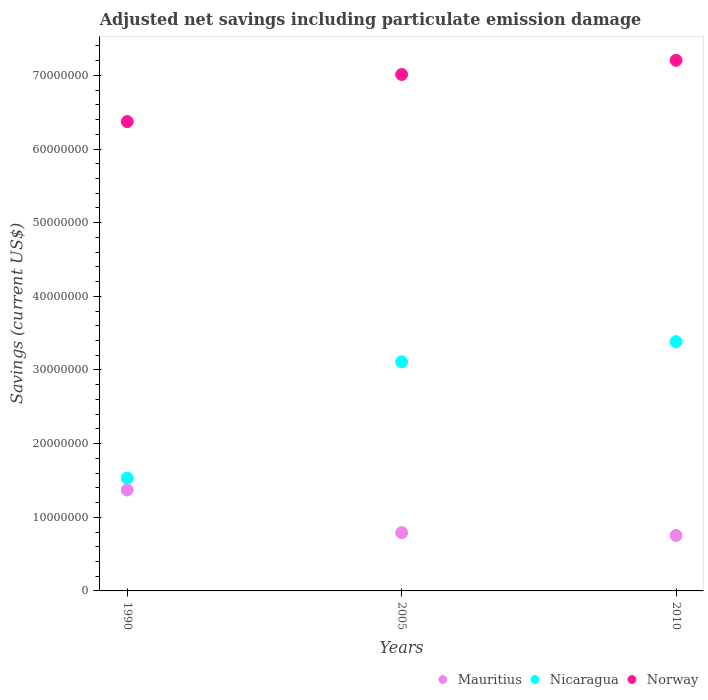How many different coloured dotlines are there?
Your answer should be compact. 3. Is the number of dotlines equal to the number of legend labels?
Offer a terse response. Yes. What is the net savings in Mauritius in 1990?
Keep it short and to the point. 1.37e+07. Across all years, what is the maximum net savings in Mauritius?
Offer a very short reply. 1.37e+07. Across all years, what is the minimum net savings in Norway?
Your response must be concise. 6.37e+07. In which year was the net savings in Mauritius maximum?
Provide a short and direct response. 1990. In which year was the net savings in Nicaragua minimum?
Your answer should be very brief. 1990. What is the total net savings in Norway in the graph?
Your response must be concise. 2.06e+08. What is the difference between the net savings in Nicaragua in 1990 and that in 2010?
Your response must be concise. -1.85e+07. What is the difference between the net savings in Mauritius in 2005 and the net savings in Norway in 2010?
Give a very brief answer. -6.41e+07. What is the average net savings in Nicaragua per year?
Your answer should be very brief. 2.68e+07. In the year 2005, what is the difference between the net savings in Nicaragua and net savings in Mauritius?
Your answer should be very brief. 2.32e+07. In how many years, is the net savings in Norway greater than 10000000 US$?
Provide a succinct answer. 3. What is the ratio of the net savings in Nicaragua in 1990 to that in 2005?
Offer a very short reply. 0.49. Is the difference between the net savings in Nicaragua in 1990 and 2005 greater than the difference between the net savings in Mauritius in 1990 and 2005?
Your answer should be very brief. No. What is the difference between the highest and the second highest net savings in Mauritius?
Give a very brief answer. 5.80e+06. What is the difference between the highest and the lowest net savings in Nicaragua?
Make the answer very short. 1.85e+07. In how many years, is the net savings in Norway greater than the average net savings in Norway taken over all years?
Your answer should be compact. 2. Is the sum of the net savings in Nicaragua in 1990 and 2005 greater than the maximum net savings in Norway across all years?
Your answer should be compact. No. Is the net savings in Mauritius strictly less than the net savings in Norway over the years?
Offer a very short reply. Yes. What is the difference between two consecutive major ticks on the Y-axis?
Keep it short and to the point. 1.00e+07. Are the values on the major ticks of Y-axis written in scientific E-notation?
Your response must be concise. No. Does the graph contain grids?
Offer a terse response. No. What is the title of the graph?
Your response must be concise. Adjusted net savings including particulate emission damage. Does "Mozambique" appear as one of the legend labels in the graph?
Provide a short and direct response. No. What is the label or title of the X-axis?
Your answer should be very brief. Years. What is the label or title of the Y-axis?
Make the answer very short. Savings (current US$). What is the Savings (current US$) of Mauritius in 1990?
Ensure brevity in your answer.  1.37e+07. What is the Savings (current US$) of Nicaragua in 1990?
Provide a short and direct response. 1.53e+07. What is the Savings (current US$) of Norway in 1990?
Ensure brevity in your answer.  6.37e+07. What is the Savings (current US$) of Mauritius in 2005?
Provide a short and direct response. 7.91e+06. What is the Savings (current US$) in Nicaragua in 2005?
Your answer should be very brief. 3.11e+07. What is the Savings (current US$) of Norway in 2005?
Provide a short and direct response. 7.01e+07. What is the Savings (current US$) of Mauritius in 2010?
Give a very brief answer. 7.53e+06. What is the Savings (current US$) of Nicaragua in 2010?
Provide a succinct answer. 3.38e+07. What is the Savings (current US$) of Norway in 2010?
Keep it short and to the point. 7.21e+07. Across all years, what is the maximum Savings (current US$) of Mauritius?
Ensure brevity in your answer.  1.37e+07. Across all years, what is the maximum Savings (current US$) of Nicaragua?
Your response must be concise. 3.38e+07. Across all years, what is the maximum Savings (current US$) of Norway?
Ensure brevity in your answer.  7.21e+07. Across all years, what is the minimum Savings (current US$) in Mauritius?
Give a very brief answer. 7.53e+06. Across all years, what is the minimum Savings (current US$) in Nicaragua?
Keep it short and to the point. 1.53e+07. Across all years, what is the minimum Savings (current US$) of Norway?
Ensure brevity in your answer.  6.37e+07. What is the total Savings (current US$) in Mauritius in the graph?
Offer a very short reply. 2.91e+07. What is the total Savings (current US$) in Nicaragua in the graph?
Offer a terse response. 8.03e+07. What is the total Savings (current US$) in Norway in the graph?
Offer a very short reply. 2.06e+08. What is the difference between the Savings (current US$) in Mauritius in 1990 and that in 2005?
Offer a terse response. 5.80e+06. What is the difference between the Savings (current US$) in Nicaragua in 1990 and that in 2005?
Provide a short and direct response. -1.58e+07. What is the difference between the Savings (current US$) of Norway in 1990 and that in 2005?
Your answer should be very brief. -6.40e+06. What is the difference between the Savings (current US$) of Mauritius in 1990 and that in 2010?
Give a very brief answer. 6.18e+06. What is the difference between the Savings (current US$) of Nicaragua in 1990 and that in 2010?
Keep it short and to the point. -1.85e+07. What is the difference between the Savings (current US$) in Norway in 1990 and that in 2010?
Provide a short and direct response. -8.32e+06. What is the difference between the Savings (current US$) of Mauritius in 2005 and that in 2010?
Your answer should be compact. 3.81e+05. What is the difference between the Savings (current US$) in Nicaragua in 2005 and that in 2010?
Your response must be concise. -2.74e+06. What is the difference between the Savings (current US$) in Norway in 2005 and that in 2010?
Offer a very short reply. -1.92e+06. What is the difference between the Savings (current US$) in Mauritius in 1990 and the Savings (current US$) in Nicaragua in 2005?
Offer a very short reply. -1.74e+07. What is the difference between the Savings (current US$) in Mauritius in 1990 and the Savings (current US$) in Norway in 2005?
Your answer should be very brief. -5.64e+07. What is the difference between the Savings (current US$) in Nicaragua in 1990 and the Savings (current US$) in Norway in 2005?
Your answer should be compact. -5.48e+07. What is the difference between the Savings (current US$) of Mauritius in 1990 and the Savings (current US$) of Nicaragua in 2010?
Ensure brevity in your answer.  -2.01e+07. What is the difference between the Savings (current US$) of Mauritius in 1990 and the Savings (current US$) of Norway in 2010?
Offer a very short reply. -5.83e+07. What is the difference between the Savings (current US$) in Nicaragua in 1990 and the Savings (current US$) in Norway in 2010?
Ensure brevity in your answer.  -5.67e+07. What is the difference between the Savings (current US$) of Mauritius in 2005 and the Savings (current US$) of Nicaragua in 2010?
Offer a terse response. -2.59e+07. What is the difference between the Savings (current US$) in Mauritius in 2005 and the Savings (current US$) in Norway in 2010?
Offer a terse response. -6.41e+07. What is the difference between the Savings (current US$) of Nicaragua in 2005 and the Savings (current US$) of Norway in 2010?
Your answer should be very brief. -4.09e+07. What is the average Savings (current US$) of Mauritius per year?
Keep it short and to the point. 9.71e+06. What is the average Savings (current US$) in Nicaragua per year?
Keep it short and to the point. 2.68e+07. What is the average Savings (current US$) of Norway per year?
Offer a very short reply. 6.86e+07. In the year 1990, what is the difference between the Savings (current US$) in Mauritius and Savings (current US$) in Nicaragua?
Give a very brief answer. -1.61e+06. In the year 1990, what is the difference between the Savings (current US$) in Mauritius and Savings (current US$) in Norway?
Offer a terse response. -5.00e+07. In the year 1990, what is the difference between the Savings (current US$) of Nicaragua and Savings (current US$) of Norway?
Give a very brief answer. -4.84e+07. In the year 2005, what is the difference between the Savings (current US$) of Mauritius and Savings (current US$) of Nicaragua?
Ensure brevity in your answer.  -2.32e+07. In the year 2005, what is the difference between the Savings (current US$) of Mauritius and Savings (current US$) of Norway?
Give a very brief answer. -6.22e+07. In the year 2005, what is the difference between the Savings (current US$) of Nicaragua and Savings (current US$) of Norway?
Provide a short and direct response. -3.90e+07. In the year 2010, what is the difference between the Savings (current US$) of Mauritius and Savings (current US$) of Nicaragua?
Provide a succinct answer. -2.63e+07. In the year 2010, what is the difference between the Savings (current US$) in Mauritius and Savings (current US$) in Norway?
Offer a very short reply. -6.45e+07. In the year 2010, what is the difference between the Savings (current US$) of Nicaragua and Savings (current US$) of Norway?
Give a very brief answer. -3.82e+07. What is the ratio of the Savings (current US$) of Mauritius in 1990 to that in 2005?
Give a very brief answer. 1.73. What is the ratio of the Savings (current US$) in Nicaragua in 1990 to that in 2005?
Offer a terse response. 0.49. What is the ratio of the Savings (current US$) in Norway in 1990 to that in 2005?
Provide a short and direct response. 0.91. What is the ratio of the Savings (current US$) of Mauritius in 1990 to that in 2010?
Ensure brevity in your answer.  1.82. What is the ratio of the Savings (current US$) of Nicaragua in 1990 to that in 2010?
Give a very brief answer. 0.45. What is the ratio of the Savings (current US$) in Norway in 1990 to that in 2010?
Give a very brief answer. 0.88. What is the ratio of the Savings (current US$) in Mauritius in 2005 to that in 2010?
Give a very brief answer. 1.05. What is the ratio of the Savings (current US$) of Nicaragua in 2005 to that in 2010?
Give a very brief answer. 0.92. What is the ratio of the Savings (current US$) of Norway in 2005 to that in 2010?
Give a very brief answer. 0.97. What is the difference between the highest and the second highest Savings (current US$) in Mauritius?
Offer a terse response. 5.80e+06. What is the difference between the highest and the second highest Savings (current US$) in Nicaragua?
Your answer should be very brief. 2.74e+06. What is the difference between the highest and the second highest Savings (current US$) in Norway?
Give a very brief answer. 1.92e+06. What is the difference between the highest and the lowest Savings (current US$) in Mauritius?
Give a very brief answer. 6.18e+06. What is the difference between the highest and the lowest Savings (current US$) in Nicaragua?
Ensure brevity in your answer.  1.85e+07. What is the difference between the highest and the lowest Savings (current US$) of Norway?
Your answer should be compact. 8.32e+06. 